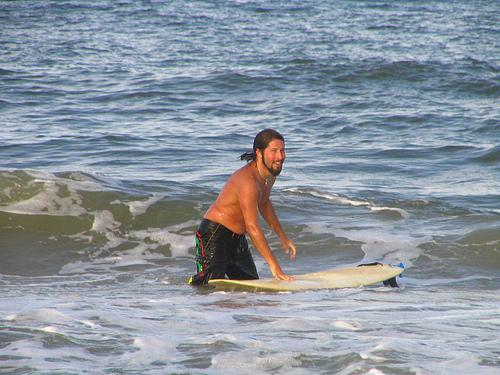Question: who is in the photo?
Choices:
A. A man.
B. A teenager.
C. A boy.
D. A woman.
Answer with the letter. Answer: A Question: what is the man doing?
Choices:
A. Scuba diving.
B. Sea surfing.
C. Swimming.
D. Floating.
Answer with the letter. Answer: B Question: how is the sea?
Choices:
A. Choppy.
B. Calm.
C. Wavy.
D. Turbulent.
Answer with the letter. Answer: C Question: what is the man holding?
Choices:
A. A longboard.
B. A wakeboard.
C. A surfboard.
D. A piece of wood.
Answer with the letter. Answer: C Question: when was the photo taken?
Choices:
A. Daytime.
B. Morning.
C. Evening.
D. Nightime.
Answer with the letter. Answer: A 